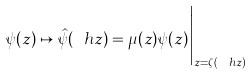Convert formula to latex. <formula><loc_0><loc_0><loc_500><loc_500>\psi ( z ) \mapsto \hat { \psi } ( \ h z ) = \mu ( z ) \psi ( z ) \Big | _ { z = \zeta ( \ h z ) }</formula> 